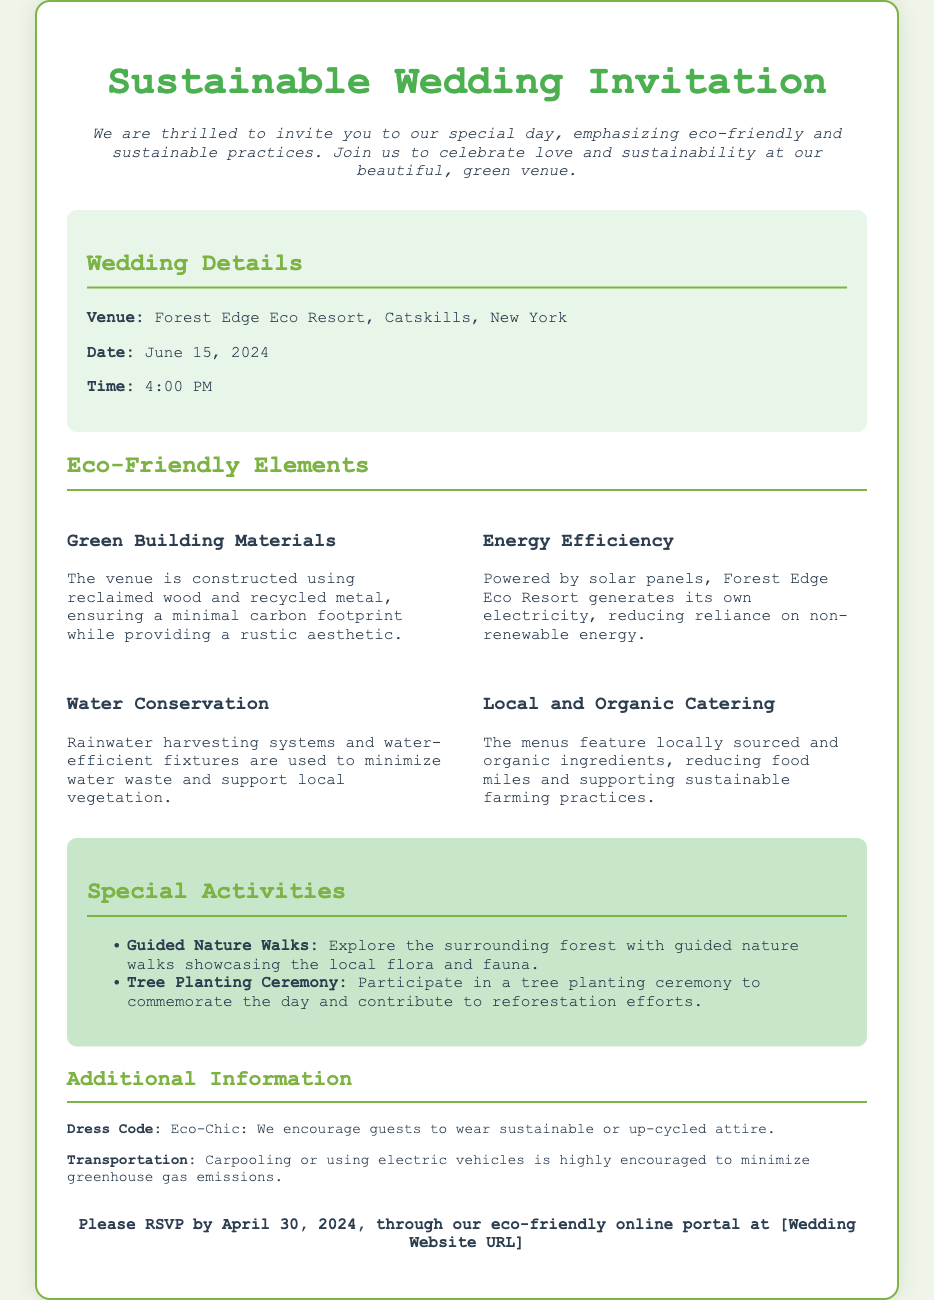What is the venue name? The venue name is mentioned in the wedding details section of the document.
Answer: Forest Edge Eco Resort What is the wedding date? The wedding date is specified under the wedding details section.
Answer: June 15, 2024 What are the guests encouraged to wear? The dress code is indicated in the additional information section.
Answer: Eco-Chic What type of catering will be provided? The catering style is described in the eco-friendly elements section.
Answer: Local and Organic What time does the wedding start? The wedding time is listed in the wedding details section.
Answer: 4:00 PM What energy source does the venue use? The energy source is described in the eco-friendly elements section.
Answer: Solar panels How many special activities are mentioned? The number of special activities can be inferred from the activities section which lists two activities.
Answer: Two What is the RSVP deadline? The RSVP deadline is provided at the end of the invitation.
Answer: April 30, 2024 What is included in the guided nature walks? The guided nature walks are described in the special activities section.
Answer: Local flora and fauna 